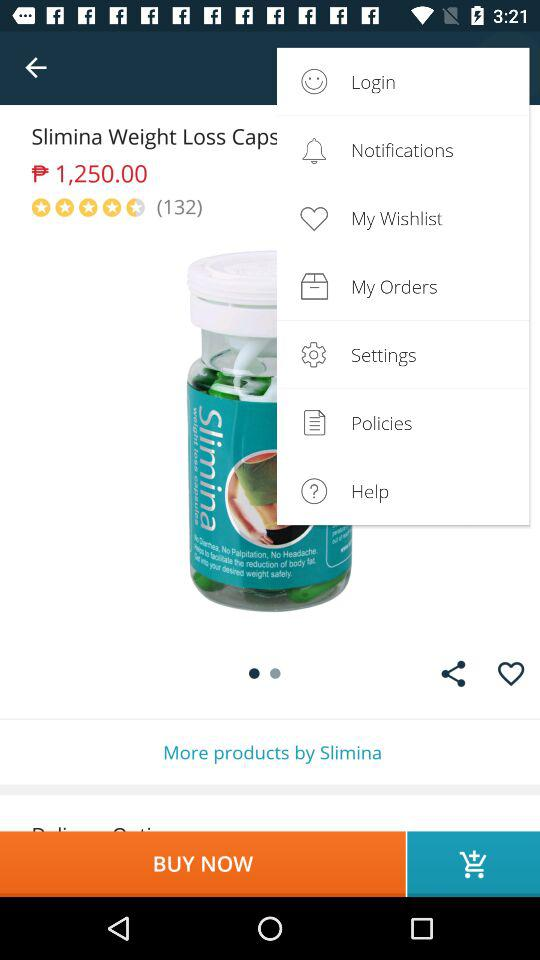What is the price of "Slimina Weight Loss Caps"? The price is ₱1,250.00. 